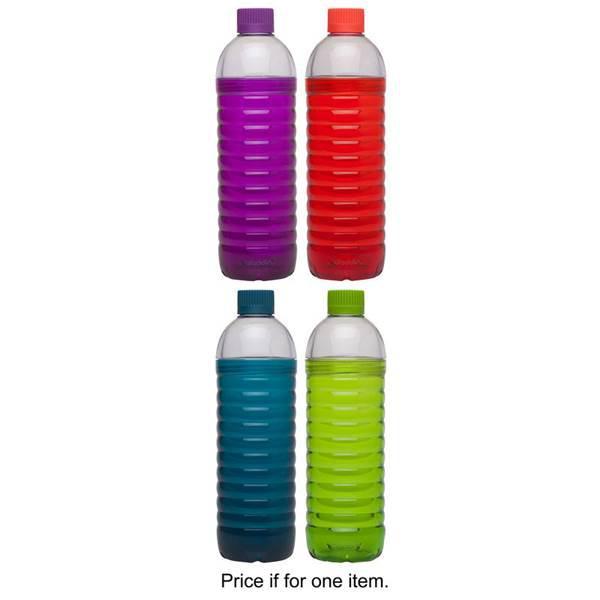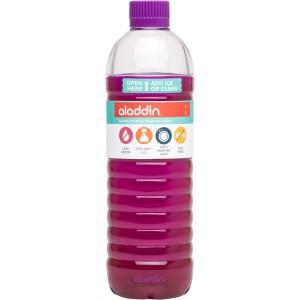The first image is the image on the left, the second image is the image on the right. For the images shown, is this caption "One bottle is filled with colored liquid and the other is filled with clear liquid." true? Answer yes or no. No. The first image is the image on the left, the second image is the image on the right. For the images shown, is this caption "An image shows a clear water bottle containing a solid-colored perforated cylindrical item inside at the bottom." true? Answer yes or no. No. 